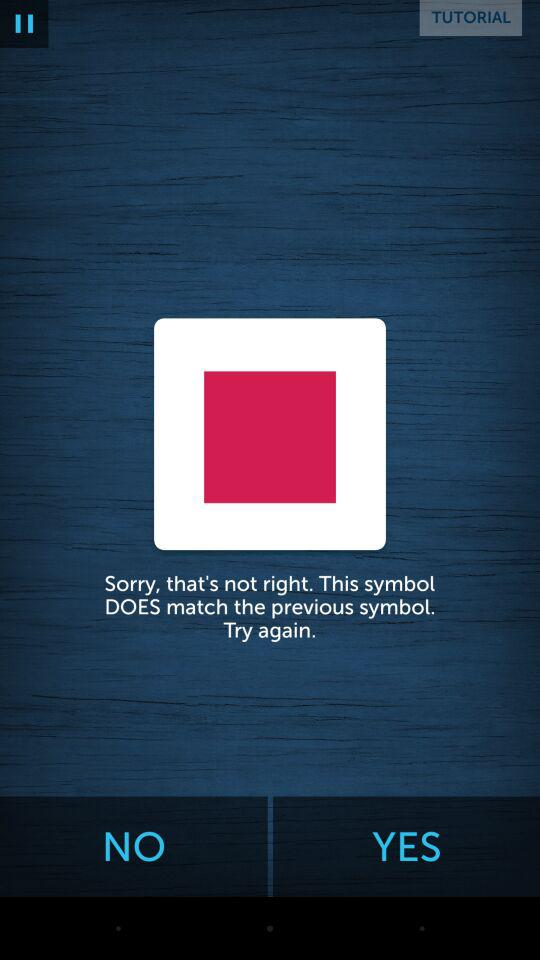What is the name of the user? The name of the user is John. 